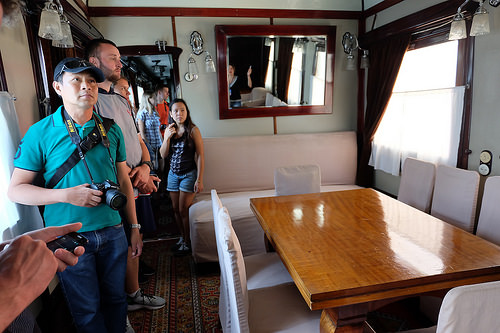<image>
Can you confirm if the girl is behind the phone? Yes. From this viewpoint, the girl is positioned behind the phone, with the phone partially or fully occluding the girl. 